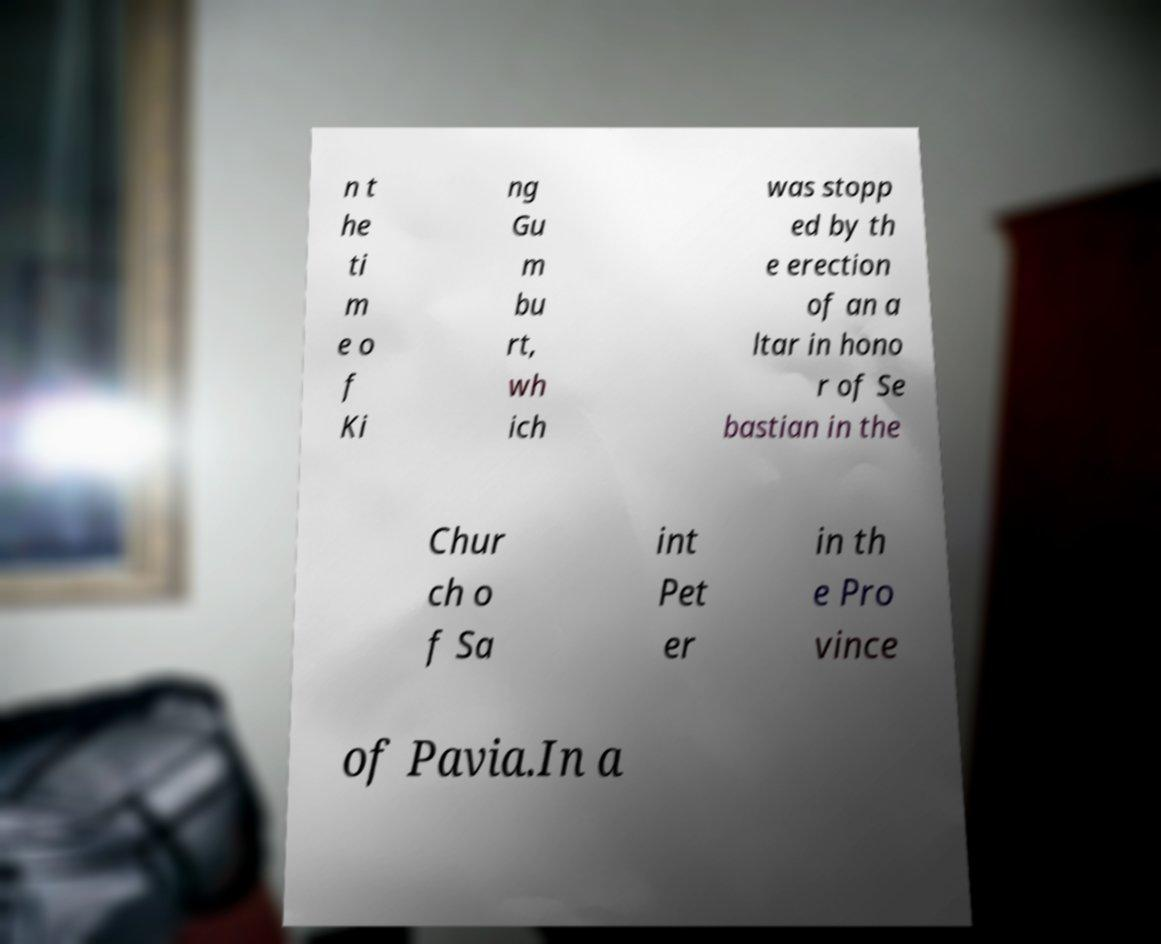For documentation purposes, I need the text within this image transcribed. Could you provide that? n t he ti m e o f Ki ng Gu m bu rt, wh ich was stopp ed by th e erection of an a ltar in hono r of Se bastian in the Chur ch o f Sa int Pet er in th e Pro vince of Pavia.In a 